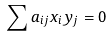Convert formula to latex. <formula><loc_0><loc_0><loc_500><loc_500>\sum a _ { i j } x _ { i } y _ { j } = 0</formula> 